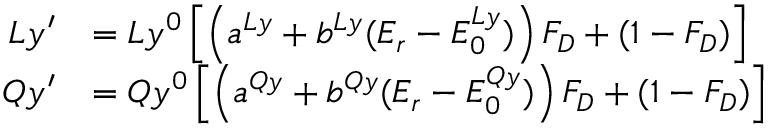Convert formula to latex. <formula><loc_0><loc_0><loc_500><loc_500>\begin{array} { r l } { L y ^ { \prime } } & { = L y ^ { 0 } \left [ \left ( a ^ { L y } + b ^ { L y } ( E _ { r } - E _ { 0 } ^ { L y } ) \right ) F _ { D } + ( 1 - F _ { D } ) \right ] } \\ { Q y ^ { \prime } } & { = Q y ^ { 0 } \left [ \left ( a ^ { Q y } + b ^ { Q y } ( E _ { r } - E _ { 0 } ^ { Q y } ) \right ) F _ { D } + ( 1 - F _ { D } ) \right ] } \end{array}</formula> 